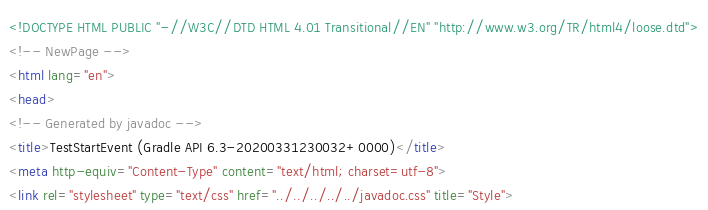Convert code to text. <code><loc_0><loc_0><loc_500><loc_500><_HTML_><!DOCTYPE HTML PUBLIC "-//W3C//DTD HTML 4.01 Transitional//EN" "http://www.w3.org/TR/html4/loose.dtd">
<!-- NewPage -->
<html lang="en">
<head>
<!-- Generated by javadoc -->
<title>TestStartEvent (Gradle API 6.3-20200331230032+0000)</title>
<meta http-equiv="Content-Type" content="text/html; charset=utf-8">
<link rel="stylesheet" type="text/css" href="../../../../../javadoc.css" title="Style"></code> 